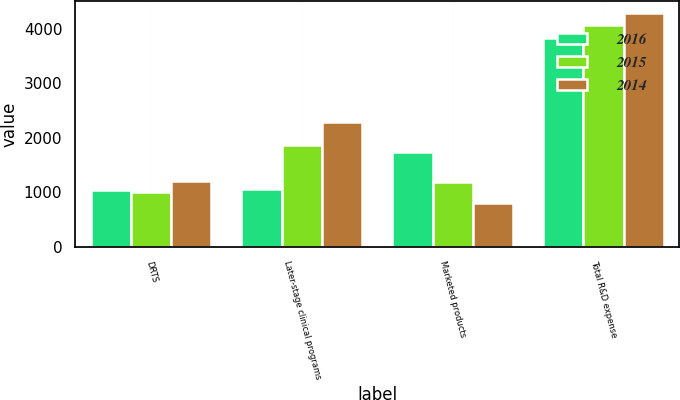Convert chart. <chart><loc_0><loc_0><loc_500><loc_500><stacked_bar_chart><ecel><fcel>DRTS<fcel>Later-stage clinical programs<fcel>Marketed products<fcel>Total R&D expense<nl><fcel>2016<fcel>1039<fcel>1054<fcel>1747<fcel>3840<nl><fcel>2015<fcel>997<fcel>1876<fcel>1197<fcel>4070<nl><fcel>2014<fcel>1212<fcel>2287<fcel>798<fcel>4297<nl></chart> 